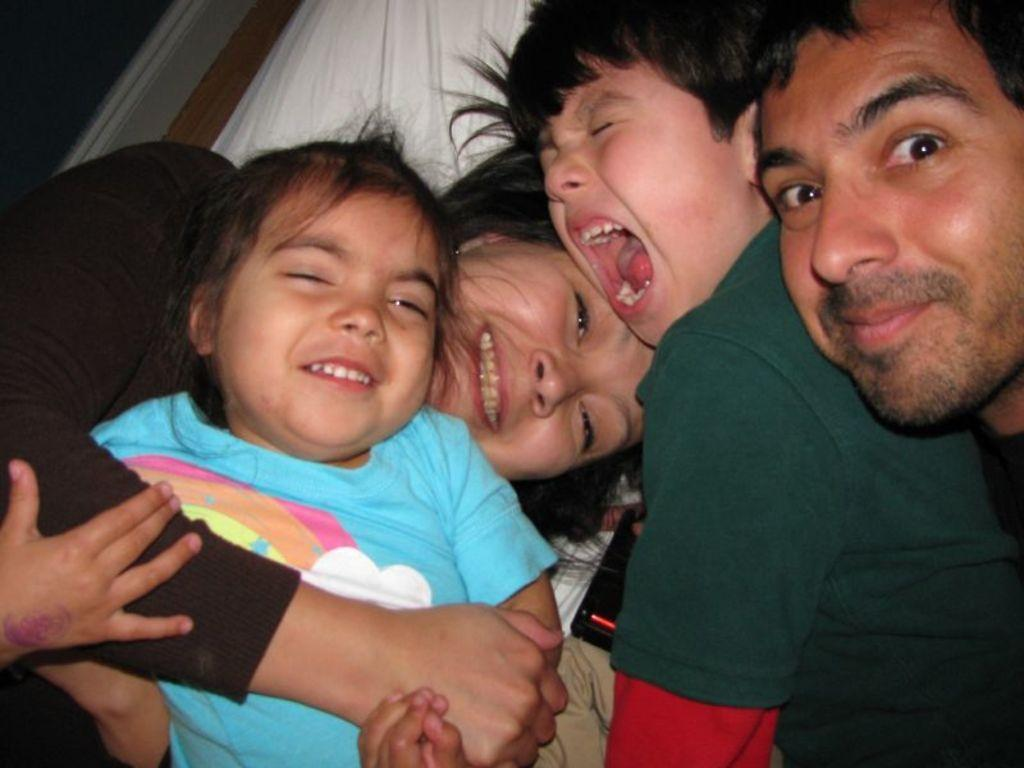How many people are in the image? There is a group of people in the image. What are the people doing in the image? The people are lying on a bed. What object can be seen in the image besides the people? There is a device present in the image. What invention is being demonstrated by the people in the image? There is no invention being demonstrated in the image; the people are simply lying on a bed. 